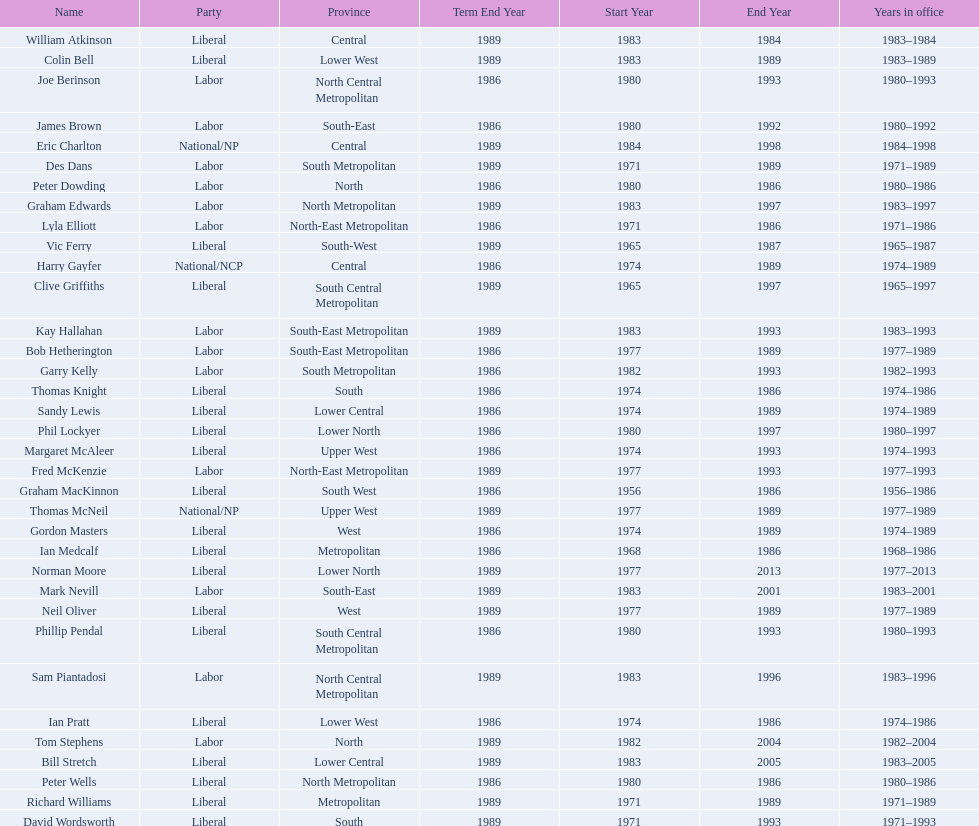What is the number of people in the liberal party? 19. 